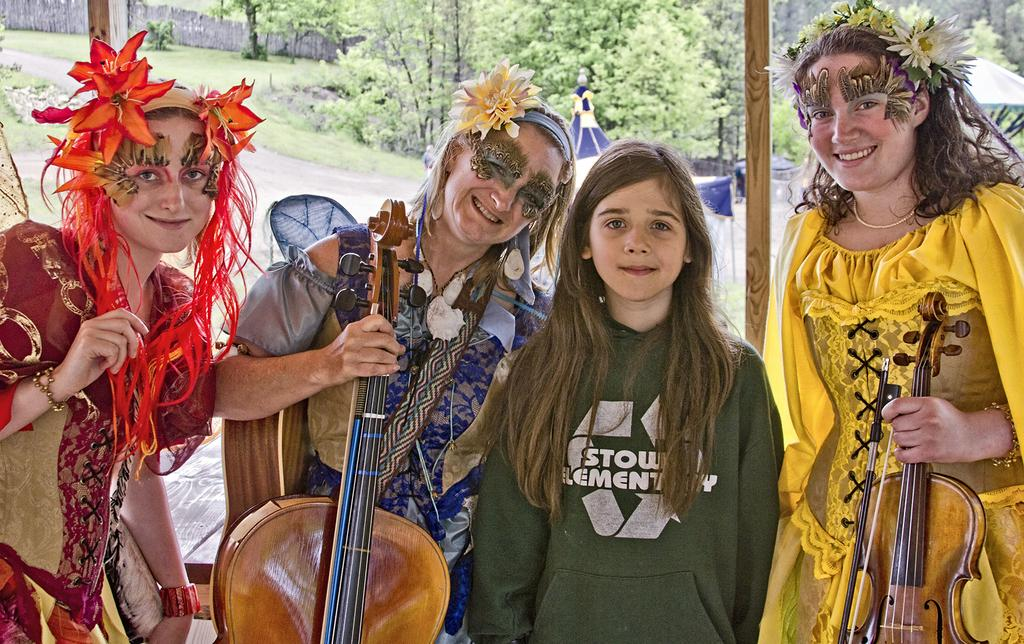How many women are in the image? There are four women in the image. What are the women doing in the image? The women are standing and holding a guitar. What is the facial expression of the women in the image? The women are smiling in the image. What can be seen in the background of the image? There are trees in the background of the image. What type of card is being used to play music on the guitar in the image? There is no card present in the image, and the guitar is being played without any cards. What type of linen can be seen draped over the trees in the background? There is no linen draped over the trees in the background; only trees are visible. 